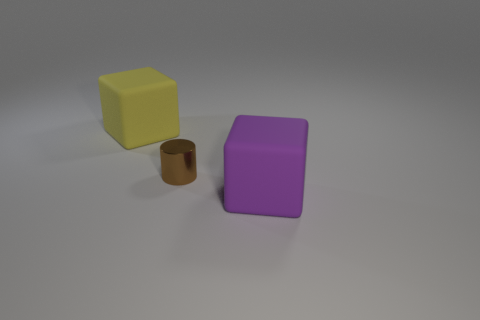There is a large yellow object that is the same shape as the big purple matte object; what is its material?
Provide a succinct answer. Rubber. What is the color of the metallic cylinder?
Your response must be concise. Brown. How many shiny things are tiny spheres or cubes?
Keep it short and to the point. 0. Are there any purple cubes on the left side of the purple block in front of the big matte thing behind the brown cylinder?
Ensure brevity in your answer.  No. There is a purple block that is made of the same material as the yellow object; what is its size?
Provide a succinct answer. Large. There is a brown metallic cylinder; are there any objects behind it?
Provide a short and direct response. Yes. Are there any small shiny cylinders on the right side of the big matte thing that is on the left side of the large purple object?
Give a very brief answer. Yes. There is a block to the left of the purple object; does it have the same size as the purple rubber block that is in front of the small shiny object?
Make the answer very short. Yes. What number of small objects are purple rubber blocks or brown metal cylinders?
Your answer should be very brief. 1. There is a big thing right of the big rubber thing that is behind the purple thing; what is it made of?
Your answer should be very brief. Rubber. 